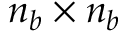<formula> <loc_0><loc_0><loc_500><loc_500>n _ { b } \times n _ { b }</formula> 